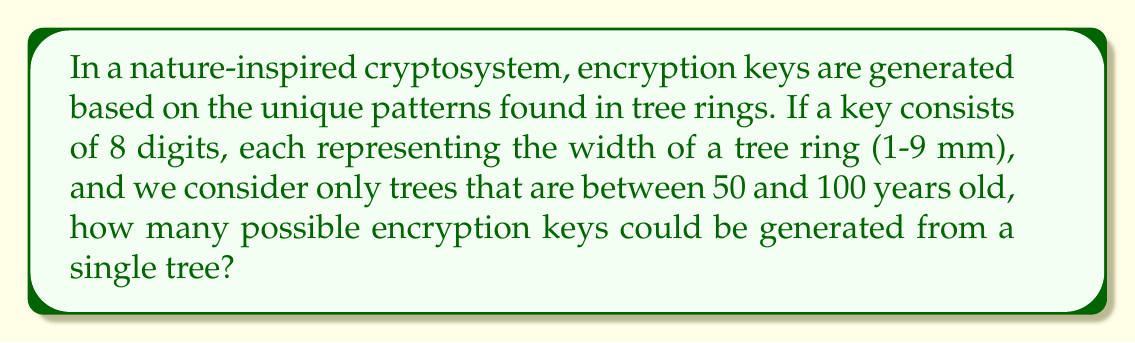Can you answer this question? Let's approach this step-by-step:

1) First, we need to determine the range of possible tree ages:
   $100 - 50 + 1 = 51$ (we add 1 to include both 50 and 100)

2) For each possible age, we need to calculate the number of ways to select 8 rings:
   This is a combination problem, represented as $\binom{n}{8}$, where $n$ is the tree's age.

3) For each selection of 8 rings, we have 9 possible widths (1-9 mm) for each ring.
   This gives us $9^8$ possibilities for each selection.

4) The total number of possible keys for a tree of age $n$ is:
   $\binom{n}{8} \cdot 9^8$

5) To get the total for all possible ages, we sum this from $n = 50$ to $100$:

   $$\sum_{n=50}^{100} \binom{n}{8} \cdot 9^8$$

6) Let's calculate $9^8$:
   $9^8 = 43,046,721$

7) Now our sum becomes:

   $$43,046,721 \cdot \sum_{n=50}^{100} \binom{n}{8}$$

8) Calculating this sum:
   
   $$\sum_{n=50}^{100} \binom{n}{8} = 1,891,512,930$$

9) Therefore, the final result is:

   $43,046,721 \cdot 1,891,512,930 = 81,423,543,670,865,930$
Answer: $81,423,543,670,865,930$ 